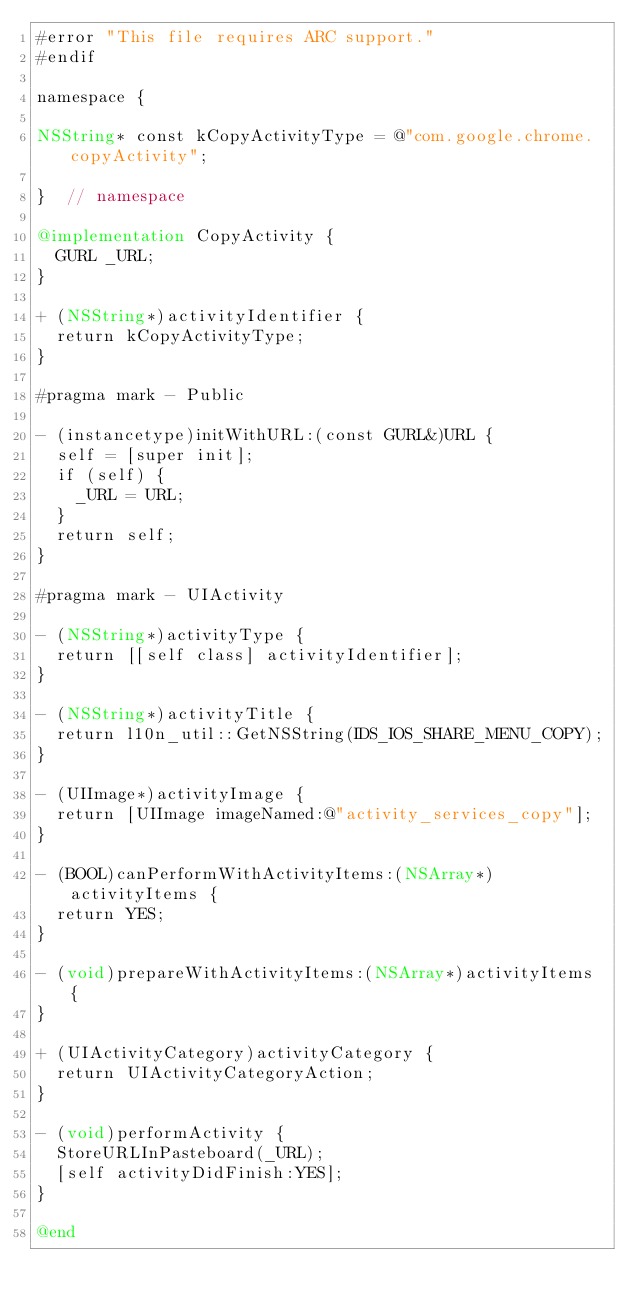<code> <loc_0><loc_0><loc_500><loc_500><_ObjectiveC_>#error "This file requires ARC support."
#endif

namespace {

NSString* const kCopyActivityType = @"com.google.chrome.copyActivity";

}  // namespace

@implementation CopyActivity {
  GURL _URL;
}

+ (NSString*)activityIdentifier {
  return kCopyActivityType;
}

#pragma mark - Public

- (instancetype)initWithURL:(const GURL&)URL {
  self = [super init];
  if (self) {
    _URL = URL;
  }
  return self;
}

#pragma mark - UIActivity

- (NSString*)activityType {
  return [[self class] activityIdentifier];
}

- (NSString*)activityTitle {
  return l10n_util::GetNSString(IDS_IOS_SHARE_MENU_COPY);
}

- (UIImage*)activityImage {
  return [UIImage imageNamed:@"activity_services_copy"];
}

- (BOOL)canPerformWithActivityItems:(NSArray*)activityItems {
  return YES;
}

- (void)prepareWithActivityItems:(NSArray*)activityItems {
}

+ (UIActivityCategory)activityCategory {
  return UIActivityCategoryAction;
}

- (void)performActivity {
  StoreURLInPasteboard(_URL);
  [self activityDidFinish:YES];
}

@end
</code> 